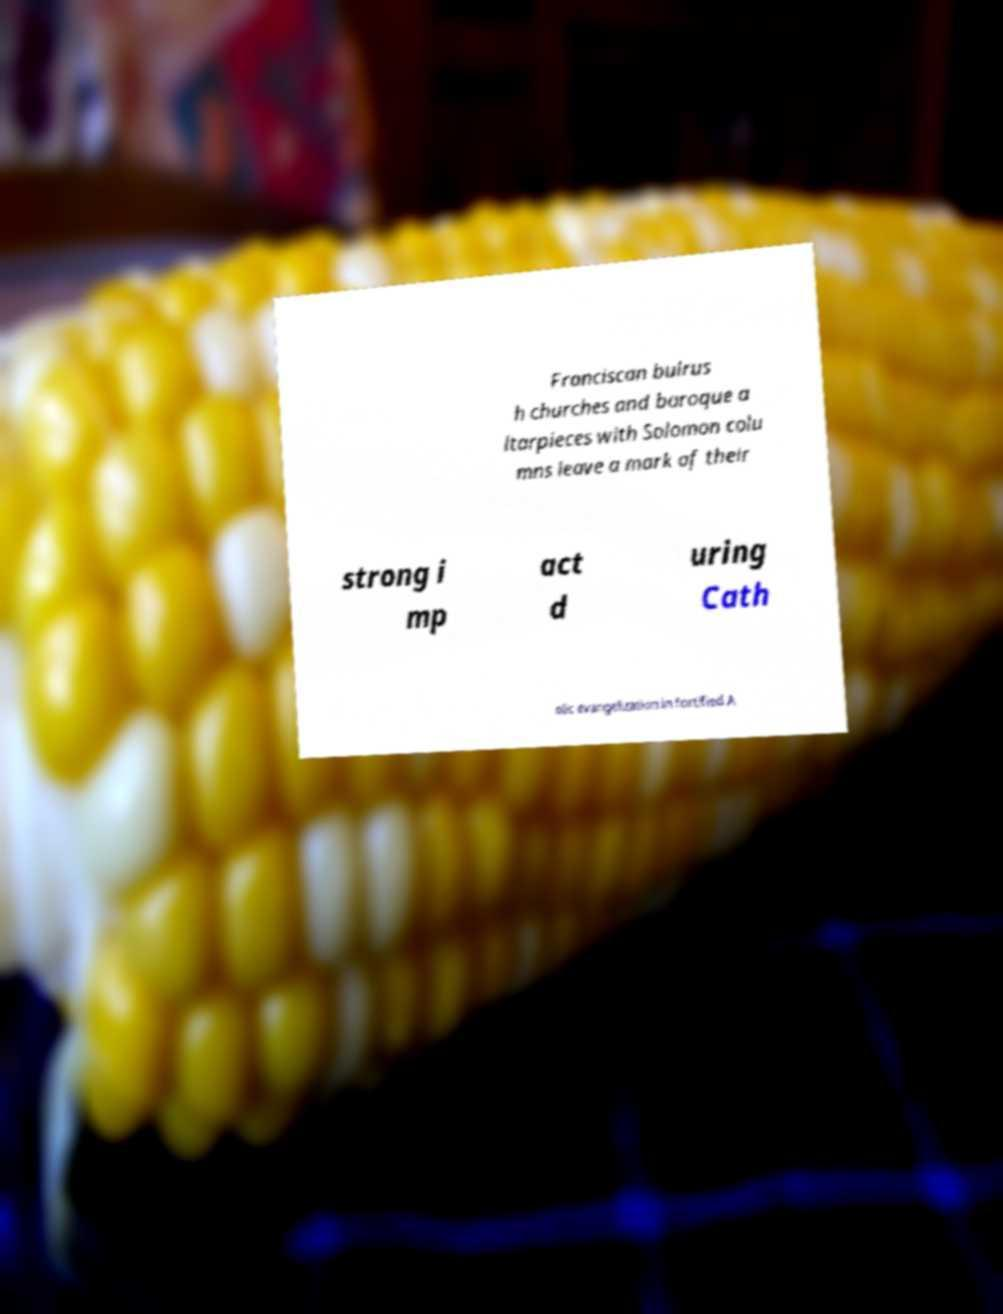There's text embedded in this image that I need extracted. Can you transcribe it verbatim? Franciscan bulrus h churches and baroque a ltarpieces with Solomon colu mns leave a mark of their strong i mp act d uring Cath olic evangelization in fortified A 